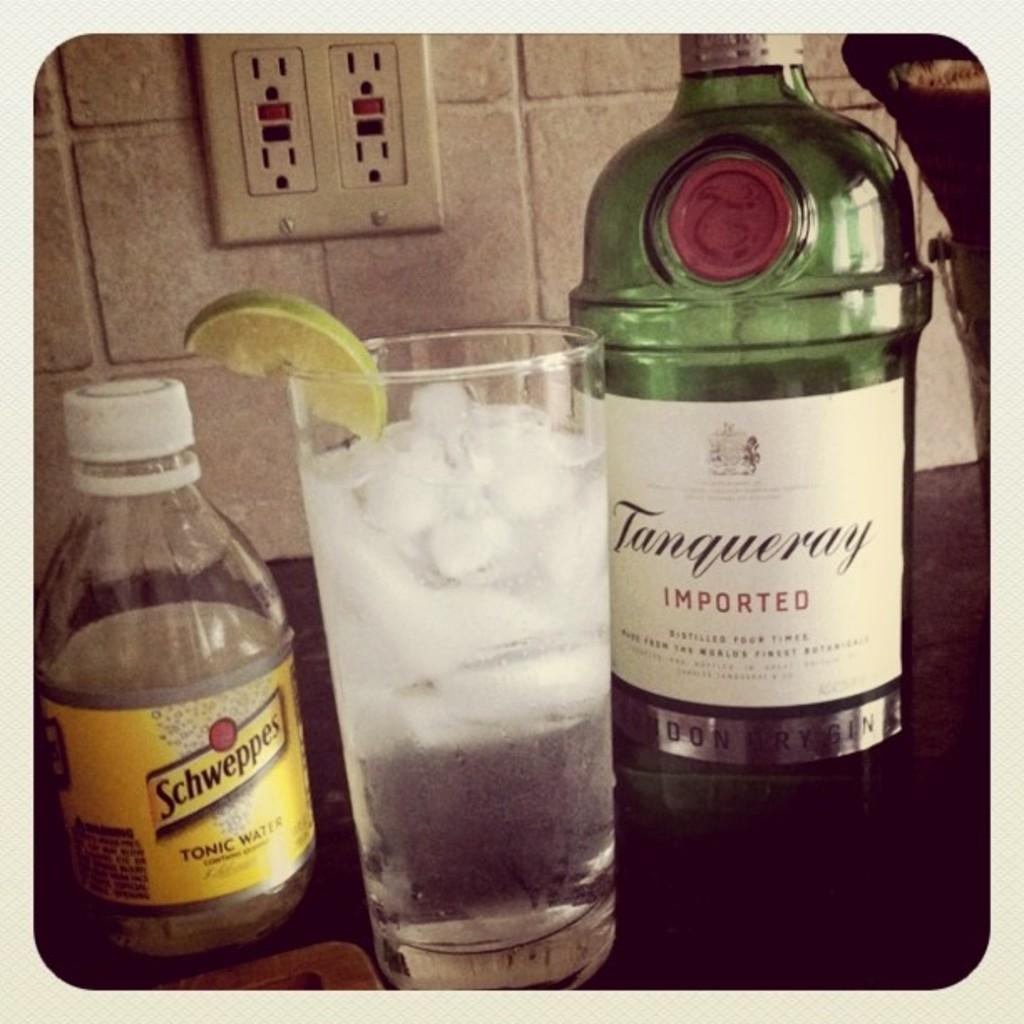Describe this image in one or two sentences. This image is taken inside a room. In this image there is a wine bottle with label on it, a glass with ice cubes and water in it and a lemon slice place on a glass and a water bottle on a table. At the background there wall and a switch board. 